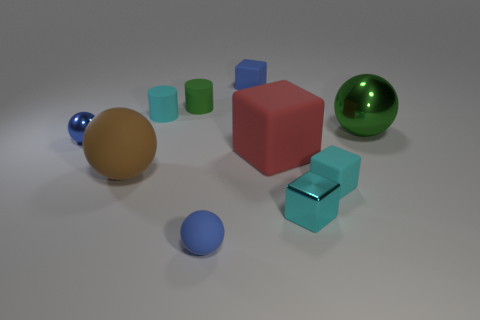What number of other objects are there of the same color as the big metallic sphere?
Offer a very short reply. 1. There is a large shiny object; is it the same color as the tiny rubber cylinder behind the cyan cylinder?
Your answer should be compact. Yes. There is another big object that is the same shape as the large metallic thing; what color is it?
Your answer should be very brief. Brown. Is the big brown object the same shape as the big green object?
Ensure brevity in your answer.  Yes. How many spheres are either brown matte objects or green matte objects?
Provide a short and direct response. 1. The large cube that is made of the same material as the tiny blue cube is what color?
Your answer should be very brief. Red. Do the cyan matte thing that is behind the blue metal ball and the cyan shiny block have the same size?
Offer a very short reply. Yes. Are the blue cube and the tiny blue thing that is in front of the tiny blue metallic object made of the same material?
Provide a short and direct response. Yes. The tiny matte block to the left of the tiny cyan rubber block is what color?
Your response must be concise. Blue. Are there any brown matte spheres in front of the blue sphere that is behind the brown thing?
Provide a short and direct response. Yes. 